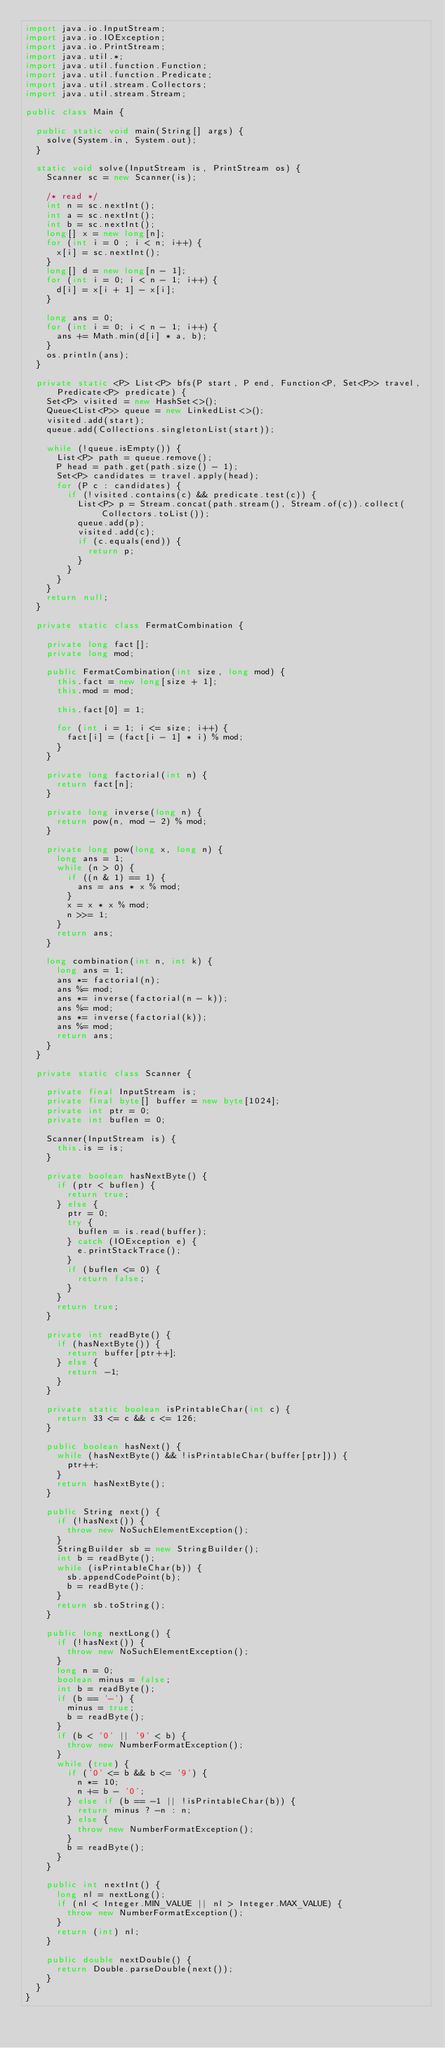Convert code to text. <code><loc_0><loc_0><loc_500><loc_500><_Java_>import java.io.InputStream;
import java.io.IOException;
import java.io.PrintStream;
import java.util.*;
import java.util.function.Function;
import java.util.function.Predicate;
import java.util.stream.Collectors;
import java.util.stream.Stream;

public class Main {

  public static void main(String[] args) {
    solve(System.in, System.out);
  }

  static void solve(InputStream is, PrintStream os) {
    Scanner sc = new Scanner(is);

    /* read */
    int n = sc.nextInt();
    int a = sc.nextInt();
    int b = sc.nextInt();
    long[] x = new long[n];
    for (int i = 0 ; i < n; i++) {
      x[i] = sc.nextInt();
    }
    long[] d = new long[n - 1];
    for (int i = 0; i < n - 1; i++) {
      d[i] = x[i + 1] - x[i];
    }

    long ans = 0;
    for (int i = 0; i < n - 1; i++) {
      ans += Math.min(d[i] * a, b);
    }
    os.println(ans);
  }

  private static <P> List<P> bfs(P start, P end, Function<P, Set<P>> travel,
      Predicate<P> predicate) {
    Set<P> visited = new HashSet<>();
    Queue<List<P>> queue = new LinkedList<>();
    visited.add(start);
    queue.add(Collections.singletonList(start));

    while (!queue.isEmpty()) {
      List<P> path = queue.remove();
      P head = path.get(path.size() - 1);
      Set<P> candidates = travel.apply(head);
      for (P c : candidates) {
        if (!visited.contains(c) && predicate.test(c)) {
          List<P> p = Stream.concat(path.stream(), Stream.of(c)).collect(Collectors.toList());
          queue.add(p);
          visited.add(c);
          if (c.equals(end)) {
            return p;
          }
        }
      }
    }
    return null;
  }

  private static class FermatCombination {

    private long fact[];
    private long mod;

    public FermatCombination(int size, long mod) {
      this.fact = new long[size + 1];
      this.mod = mod;

      this.fact[0] = 1;

      for (int i = 1; i <= size; i++) {
        fact[i] = (fact[i - 1] * i) % mod;
      }
    }

    private long factorial(int n) {
      return fact[n];
    }

    private long inverse(long n) {
      return pow(n, mod - 2) % mod;
    }

    private long pow(long x, long n) {
      long ans = 1;
      while (n > 0) {
        if ((n & 1) == 1) {
          ans = ans * x % mod;
        }
        x = x * x % mod;
        n >>= 1;
      }
      return ans;
    }

    long combination(int n, int k) {
      long ans = 1;
      ans *= factorial(n);
      ans %= mod;
      ans *= inverse(factorial(n - k));
      ans %= mod;
      ans *= inverse(factorial(k));
      ans %= mod;
      return ans;
    }
  }

  private static class Scanner {

    private final InputStream is;
    private final byte[] buffer = new byte[1024];
    private int ptr = 0;
    private int buflen = 0;

    Scanner(InputStream is) {
      this.is = is;
    }

    private boolean hasNextByte() {
      if (ptr < buflen) {
        return true;
      } else {
        ptr = 0;
        try {
          buflen = is.read(buffer);
        } catch (IOException e) {
          e.printStackTrace();
        }
        if (buflen <= 0) {
          return false;
        }
      }
      return true;
    }

    private int readByte() {
      if (hasNextByte()) {
        return buffer[ptr++];
      } else {
        return -1;
      }
    }

    private static boolean isPrintableChar(int c) {
      return 33 <= c && c <= 126;
    }

    public boolean hasNext() {
      while (hasNextByte() && !isPrintableChar(buffer[ptr])) {
        ptr++;
      }
      return hasNextByte();
    }

    public String next() {
      if (!hasNext()) {
        throw new NoSuchElementException();
      }
      StringBuilder sb = new StringBuilder();
      int b = readByte();
      while (isPrintableChar(b)) {
        sb.appendCodePoint(b);
        b = readByte();
      }
      return sb.toString();
    }

    public long nextLong() {
      if (!hasNext()) {
        throw new NoSuchElementException();
      }
      long n = 0;
      boolean minus = false;
      int b = readByte();
      if (b == '-') {
        minus = true;
        b = readByte();
      }
      if (b < '0' || '9' < b) {
        throw new NumberFormatException();
      }
      while (true) {
        if ('0' <= b && b <= '9') {
          n *= 10;
          n += b - '0';
        } else if (b == -1 || !isPrintableChar(b)) {
          return minus ? -n : n;
        } else {
          throw new NumberFormatException();
        }
        b = readByte();
      }
    }

    public int nextInt() {
      long nl = nextLong();
      if (nl < Integer.MIN_VALUE || nl > Integer.MAX_VALUE) {
        throw new NumberFormatException();
      }
      return (int) nl;
    }

    public double nextDouble() {
      return Double.parseDouble(next());
    }
  }
}
</code> 